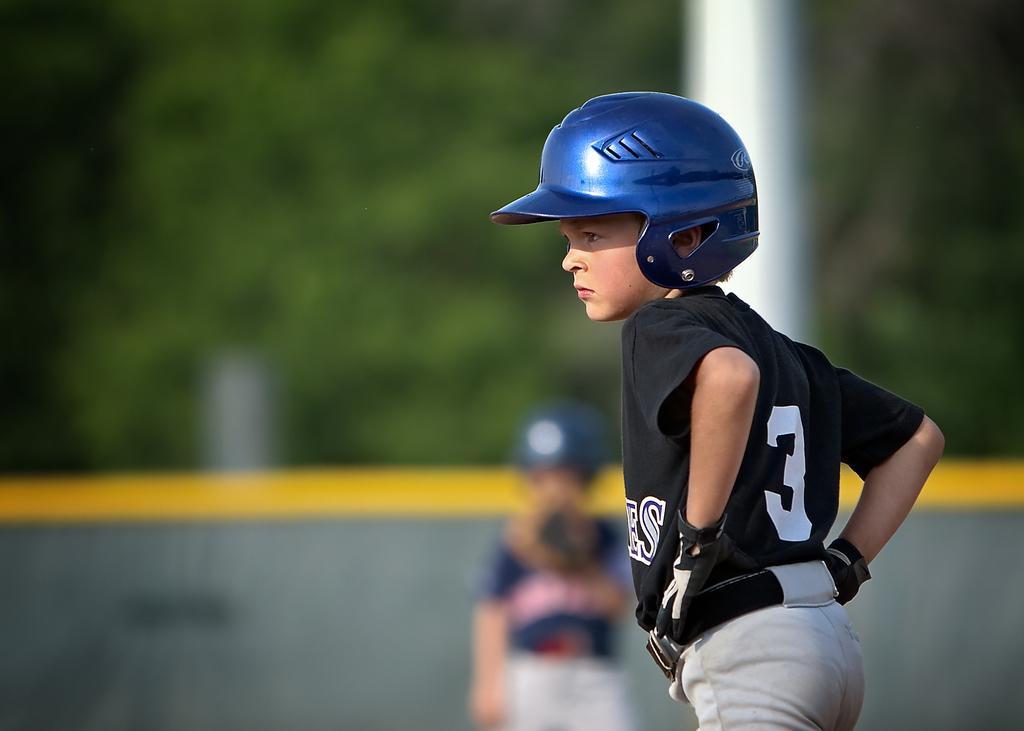Please provide a concise description of this image. In this image we can see children wearing helmets and standing on the ground. In the background there are trees. 